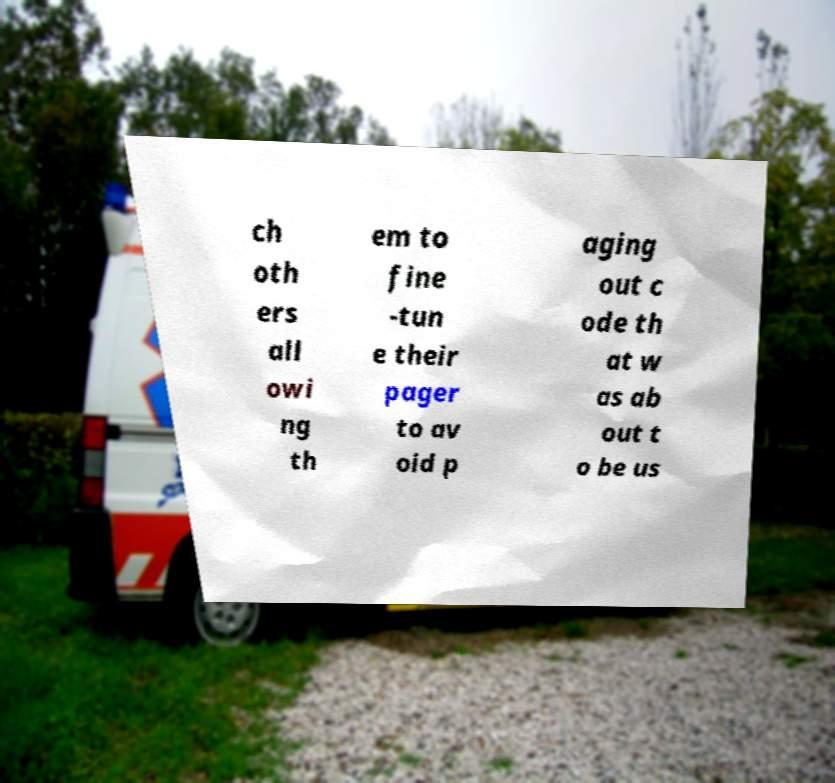Could you extract and type out the text from this image? ch oth ers all owi ng th em to fine -tun e their pager to av oid p aging out c ode th at w as ab out t o be us 